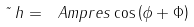Convert formula to latex. <formula><loc_0><loc_0><loc_500><loc_500>\tilde { \ } h = \ A m p r e s \cos \left ( \phi + \Phi \right )</formula> 